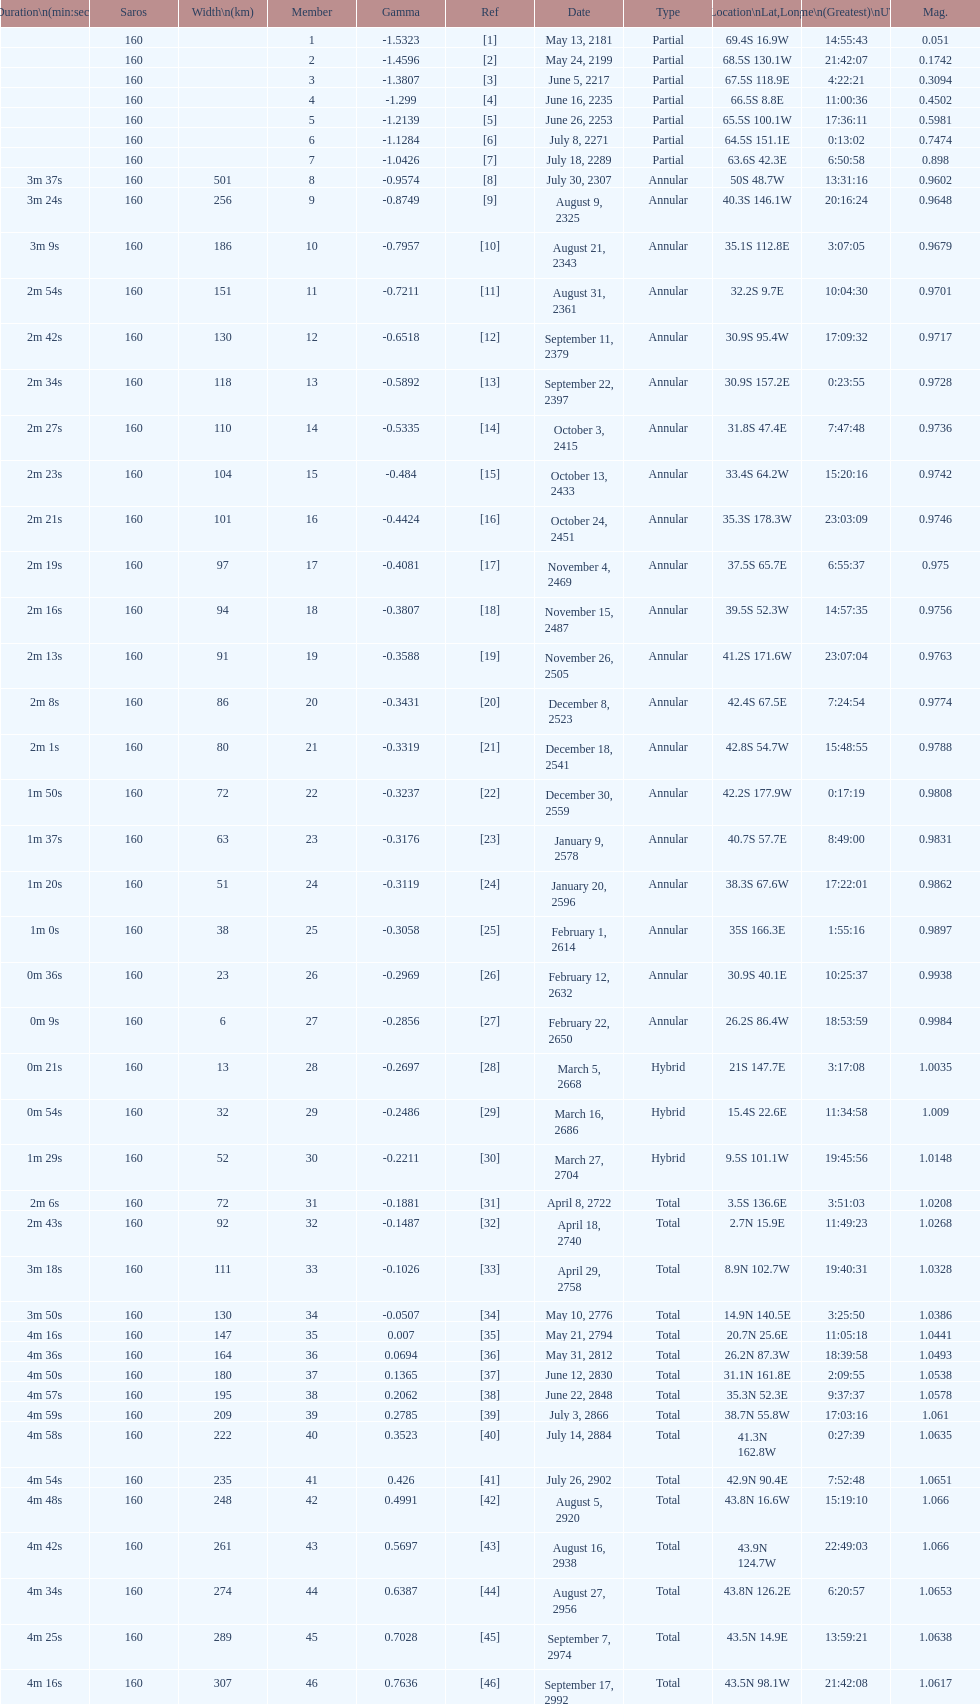I'm looking to parse the entire table for insights. Could you assist me with that? {'header': ['Duration\\n(min:sec)', 'Saros', 'Width\\n(km)', 'Member', 'Gamma', 'Ref', 'Date', 'Type', 'Location\\nLat,Long', 'Time\\n(Greatest)\\nUTC', 'Mag.'], 'rows': [['', '160', '', '1', '-1.5323', '[1]', 'May 13, 2181', 'Partial', '69.4S 16.9W', '14:55:43', '0.051'], ['', '160', '', '2', '-1.4596', '[2]', 'May 24, 2199', 'Partial', '68.5S 130.1W', '21:42:07', '0.1742'], ['', '160', '', '3', '-1.3807', '[3]', 'June 5, 2217', 'Partial', '67.5S 118.9E', '4:22:21', '0.3094'], ['', '160', '', '4', '-1.299', '[4]', 'June 16, 2235', 'Partial', '66.5S 8.8E', '11:00:36', '0.4502'], ['', '160', '', '5', '-1.2139', '[5]', 'June 26, 2253', 'Partial', '65.5S 100.1W', '17:36:11', '0.5981'], ['', '160', '', '6', '-1.1284', '[6]', 'July 8, 2271', 'Partial', '64.5S 151.1E', '0:13:02', '0.7474'], ['', '160', '', '7', '-1.0426', '[7]', 'July 18, 2289', 'Partial', '63.6S 42.3E', '6:50:58', '0.898'], ['3m 37s', '160', '501', '8', '-0.9574', '[8]', 'July 30, 2307', 'Annular', '50S 48.7W', '13:31:16', '0.9602'], ['3m 24s', '160', '256', '9', '-0.8749', '[9]', 'August 9, 2325', 'Annular', '40.3S 146.1W', '20:16:24', '0.9648'], ['3m 9s', '160', '186', '10', '-0.7957', '[10]', 'August 21, 2343', 'Annular', '35.1S 112.8E', '3:07:05', '0.9679'], ['2m 54s', '160', '151', '11', '-0.7211', '[11]', 'August 31, 2361', 'Annular', '32.2S 9.7E', '10:04:30', '0.9701'], ['2m 42s', '160', '130', '12', '-0.6518', '[12]', 'September 11, 2379', 'Annular', '30.9S 95.4W', '17:09:32', '0.9717'], ['2m 34s', '160', '118', '13', '-0.5892', '[13]', 'September 22, 2397', 'Annular', '30.9S 157.2E', '0:23:55', '0.9728'], ['2m 27s', '160', '110', '14', '-0.5335', '[14]', 'October 3, 2415', 'Annular', '31.8S 47.4E', '7:47:48', '0.9736'], ['2m 23s', '160', '104', '15', '-0.484', '[15]', 'October 13, 2433', 'Annular', '33.4S 64.2W', '15:20:16', '0.9742'], ['2m 21s', '160', '101', '16', '-0.4424', '[16]', 'October 24, 2451', 'Annular', '35.3S 178.3W', '23:03:09', '0.9746'], ['2m 19s', '160', '97', '17', '-0.4081', '[17]', 'November 4, 2469', 'Annular', '37.5S 65.7E', '6:55:37', '0.975'], ['2m 16s', '160', '94', '18', '-0.3807', '[18]', 'November 15, 2487', 'Annular', '39.5S 52.3W', '14:57:35', '0.9756'], ['2m 13s', '160', '91', '19', '-0.3588', '[19]', 'November 26, 2505', 'Annular', '41.2S 171.6W', '23:07:04', '0.9763'], ['2m 8s', '160', '86', '20', '-0.3431', '[20]', 'December 8, 2523', 'Annular', '42.4S 67.5E', '7:24:54', '0.9774'], ['2m 1s', '160', '80', '21', '-0.3319', '[21]', 'December 18, 2541', 'Annular', '42.8S 54.7W', '15:48:55', '0.9788'], ['1m 50s', '160', '72', '22', '-0.3237', '[22]', 'December 30, 2559', 'Annular', '42.2S 177.9W', '0:17:19', '0.9808'], ['1m 37s', '160', '63', '23', '-0.3176', '[23]', 'January 9, 2578', 'Annular', '40.7S 57.7E', '8:49:00', '0.9831'], ['1m 20s', '160', '51', '24', '-0.3119', '[24]', 'January 20, 2596', 'Annular', '38.3S 67.6W', '17:22:01', '0.9862'], ['1m 0s', '160', '38', '25', '-0.3058', '[25]', 'February 1, 2614', 'Annular', '35S 166.3E', '1:55:16', '0.9897'], ['0m 36s', '160', '23', '26', '-0.2969', '[26]', 'February 12, 2632', 'Annular', '30.9S 40.1E', '10:25:37', '0.9938'], ['0m 9s', '160', '6', '27', '-0.2856', '[27]', 'February 22, 2650', 'Annular', '26.2S 86.4W', '18:53:59', '0.9984'], ['0m 21s', '160', '13', '28', '-0.2697', '[28]', 'March 5, 2668', 'Hybrid', '21S 147.7E', '3:17:08', '1.0035'], ['0m 54s', '160', '32', '29', '-0.2486', '[29]', 'March 16, 2686', 'Hybrid', '15.4S 22.6E', '11:34:58', '1.009'], ['1m 29s', '160', '52', '30', '-0.2211', '[30]', 'March 27, 2704', 'Hybrid', '9.5S 101.1W', '19:45:56', '1.0148'], ['2m 6s', '160', '72', '31', '-0.1881', '[31]', 'April 8, 2722', 'Total', '3.5S 136.6E', '3:51:03', '1.0208'], ['2m 43s', '160', '92', '32', '-0.1487', '[32]', 'April 18, 2740', 'Total', '2.7N 15.9E', '11:49:23', '1.0268'], ['3m 18s', '160', '111', '33', '-0.1026', '[33]', 'April 29, 2758', 'Total', '8.9N 102.7W', '19:40:31', '1.0328'], ['3m 50s', '160', '130', '34', '-0.0507', '[34]', 'May 10, 2776', 'Total', '14.9N 140.5E', '3:25:50', '1.0386'], ['4m 16s', '160', '147', '35', '0.007', '[35]', 'May 21, 2794', 'Total', '20.7N 25.6E', '11:05:18', '1.0441'], ['4m 36s', '160', '164', '36', '0.0694', '[36]', 'May 31, 2812', 'Total', '26.2N 87.3W', '18:39:58', '1.0493'], ['4m 50s', '160', '180', '37', '0.1365', '[37]', 'June 12, 2830', 'Total', '31.1N 161.8E', '2:09:55', '1.0538'], ['4m 57s', '160', '195', '38', '0.2062', '[38]', 'June 22, 2848', 'Total', '35.3N 52.3E', '9:37:37', '1.0578'], ['4m 59s', '160', '209', '39', '0.2785', '[39]', 'July 3, 2866', 'Total', '38.7N 55.8W', '17:03:16', '1.061'], ['4m 58s', '160', '222', '40', '0.3523', '[40]', 'July 14, 2884', 'Total', '41.3N 162.8W', '0:27:39', '1.0635'], ['4m 54s', '160', '235', '41', '0.426', '[41]', 'July 26, 2902', 'Total', '42.9N 90.4E', '7:52:48', '1.0651'], ['4m 48s', '160', '248', '42', '0.4991', '[42]', 'August 5, 2920', 'Total', '43.8N 16.6W', '15:19:10', '1.066'], ['4m 42s', '160', '261', '43', '0.5697', '[43]', 'August 16, 2938', 'Total', '43.9N 124.7W', '22:49:03', '1.066'], ['4m 34s', '160', '274', '44', '0.6387', '[44]', 'August 27, 2956', 'Total', '43.8N 126.2E', '6:20:57', '1.0653'], ['4m 25s', '160', '289', '45', '0.7028', '[45]', 'September 7, 2974', 'Total', '43.5N 14.9E', '13:59:21', '1.0638'], ['4m 16s', '160', '307', '46', '0.7636', '[46]', 'September 17, 2992', 'Total', '43.5N 98.1W', '21:42:08', '1.0617']]} Name a member number with a latitude above 60 s. 1. 